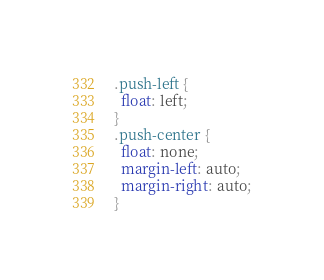<code> <loc_0><loc_0><loc_500><loc_500><_CSS_>.push-left {
  float: left;
}
.push-center {
  float: none;
  margin-left: auto;
  margin-right: auto;
}</code> 